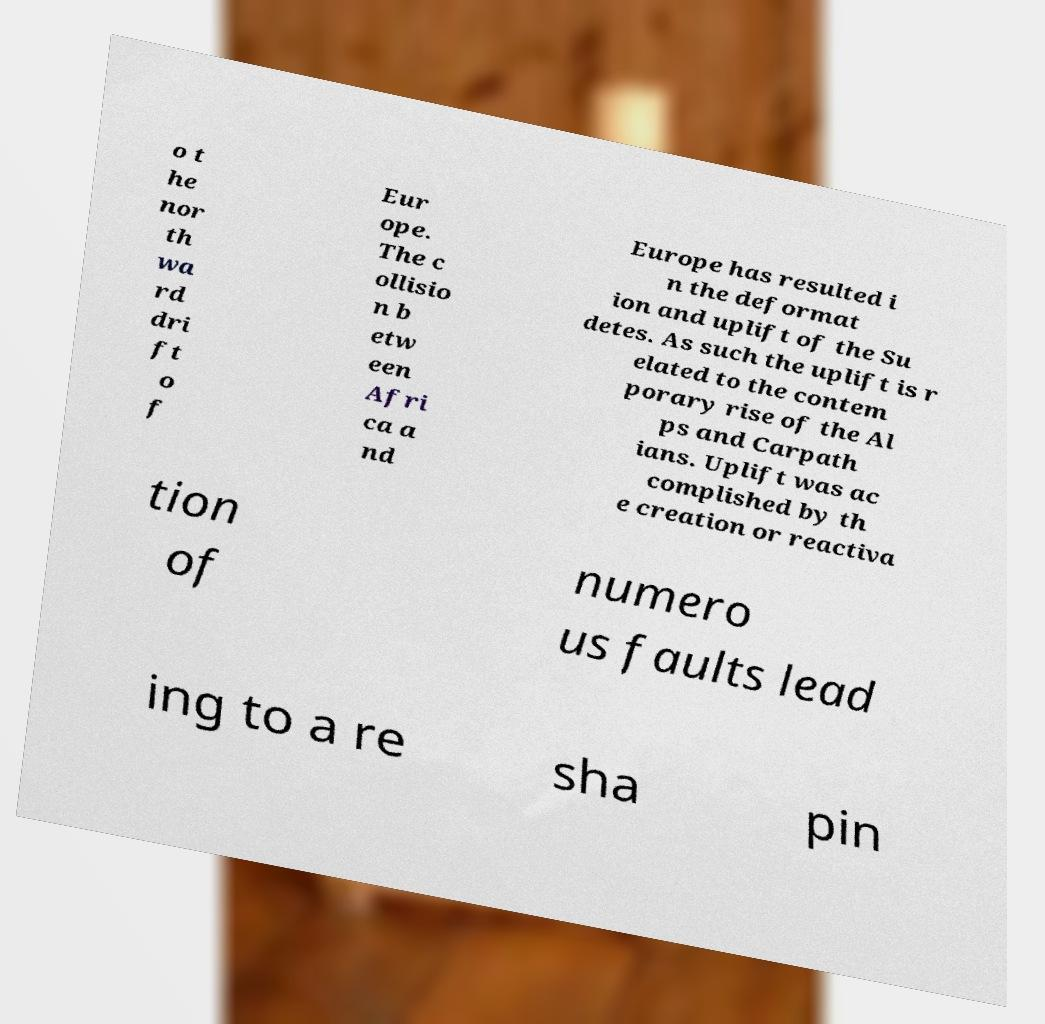Can you read and provide the text displayed in the image?This photo seems to have some interesting text. Can you extract and type it out for me? o t he nor th wa rd dri ft o f Eur ope. The c ollisio n b etw een Afri ca a nd Europe has resulted i n the deformat ion and uplift of the Su detes. As such the uplift is r elated to the contem porary rise of the Al ps and Carpath ians. Uplift was ac complished by th e creation or reactiva tion of numero us faults lead ing to a re sha pin 